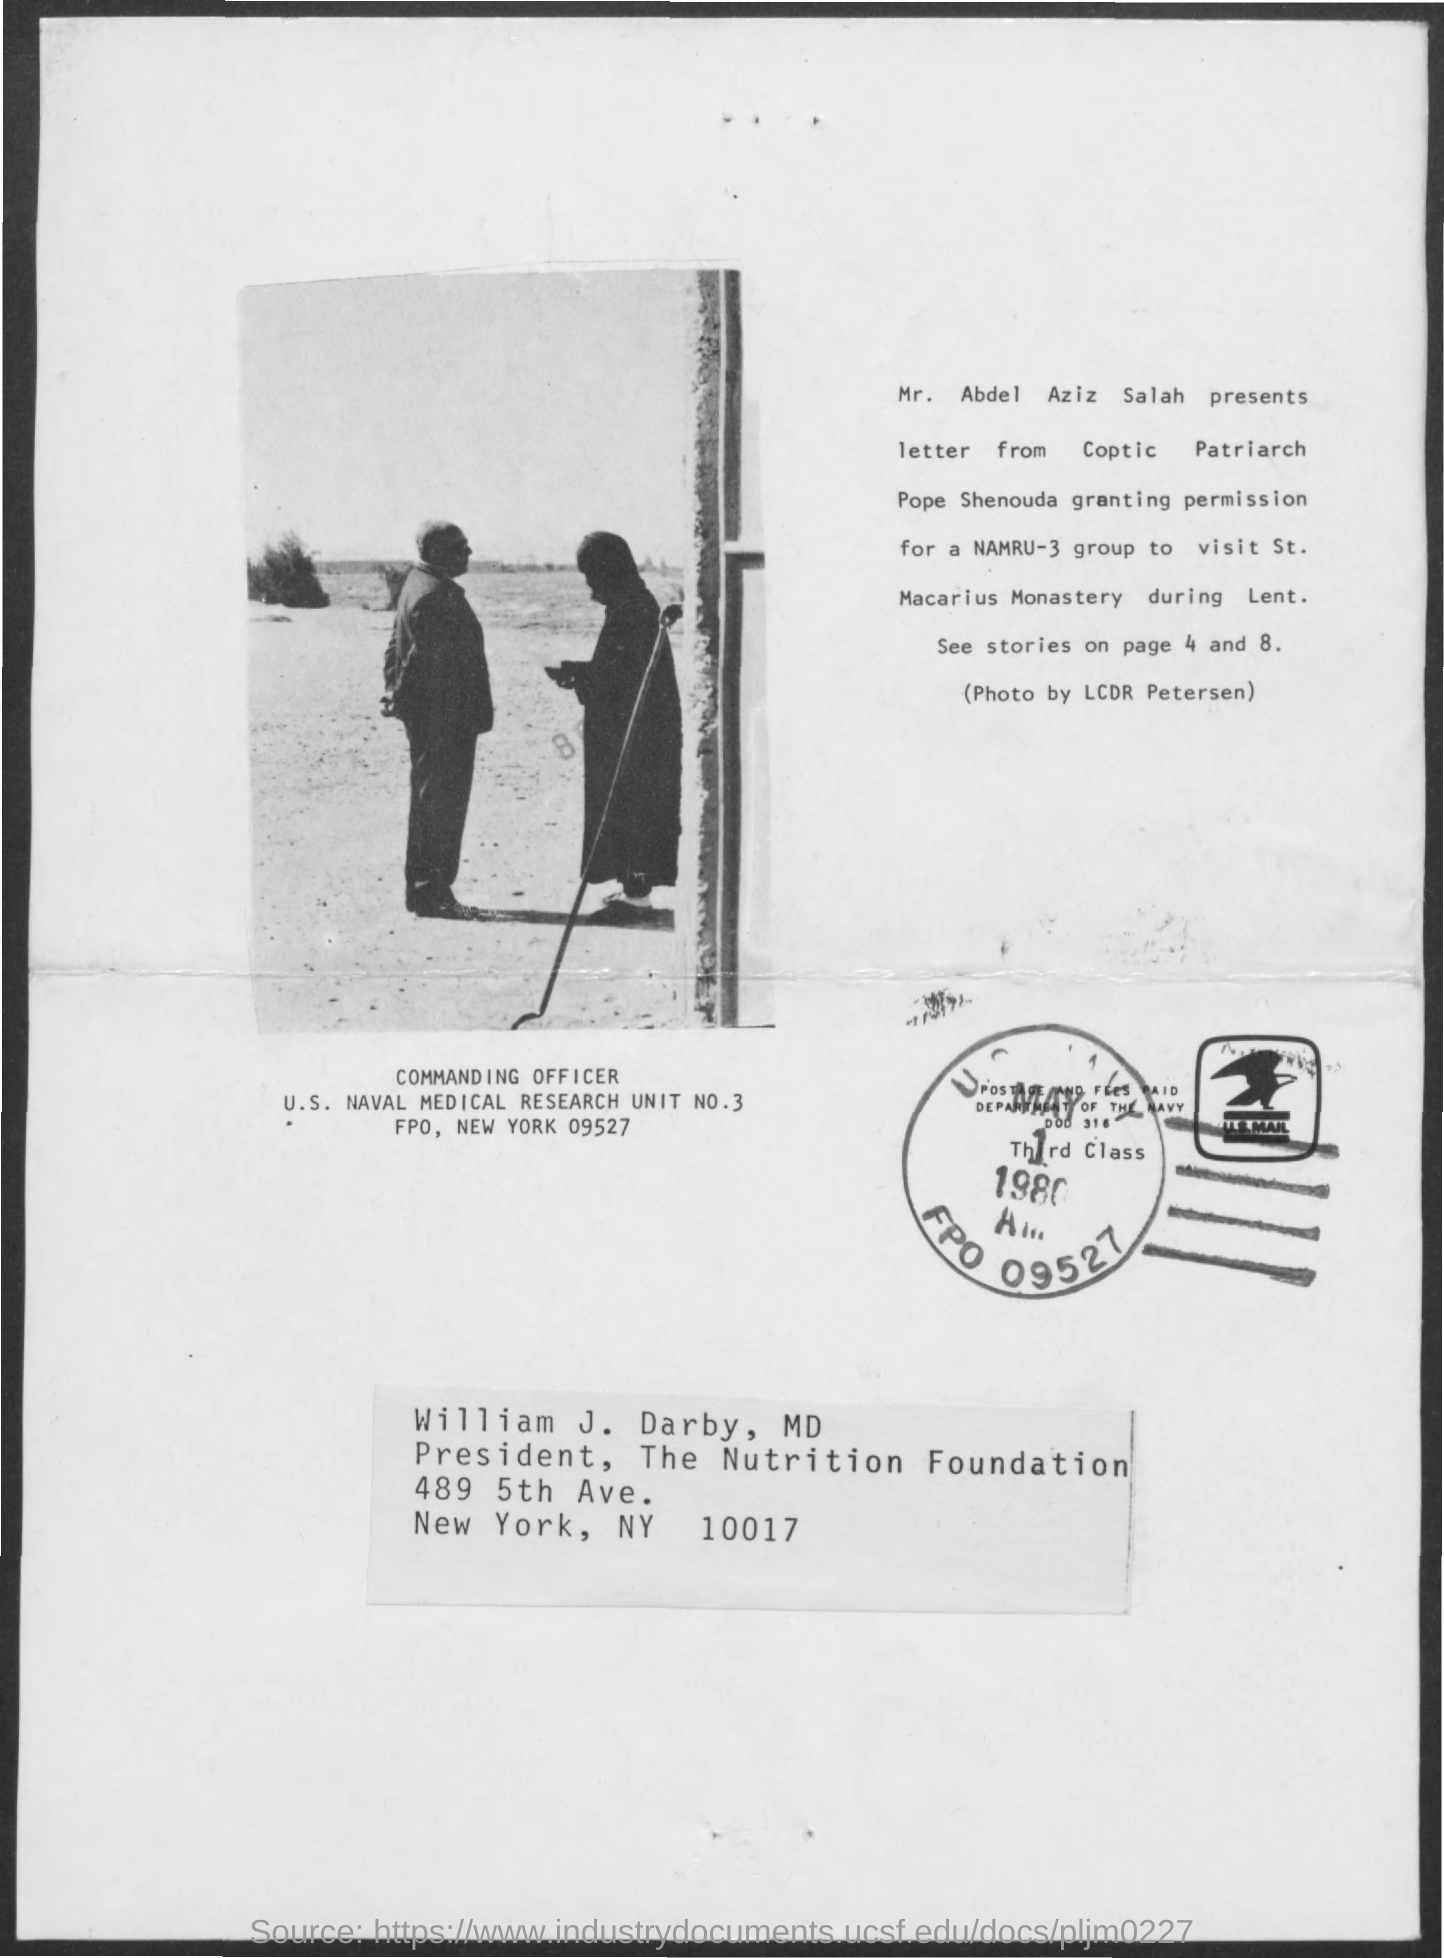Specify some key components in this picture. I hereby grant permission to NAMRU-3 GROUP to access this document. The permission was granted to visit St. Macarius Monastery. The letter is from Mr. Abdel Aziz Salah, and it was presented by Pope Shenouda, the Coptic Patriarch. Mr. Abdel Aziz Salah presents the letter. 